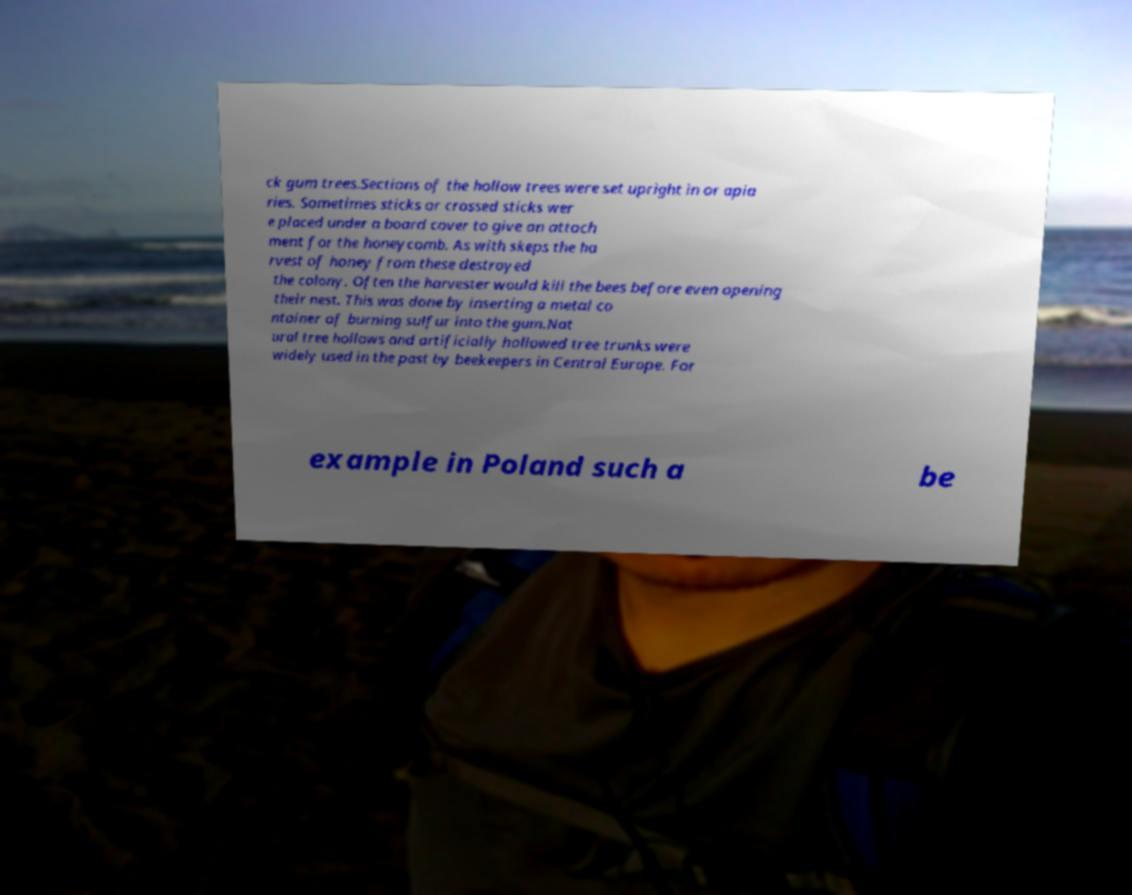Could you extract and type out the text from this image? ck gum trees.Sections of the hollow trees were set upright in or apia ries. Sometimes sticks or crossed sticks wer e placed under a board cover to give an attach ment for the honeycomb. As with skeps the ha rvest of honey from these destroyed the colony. Often the harvester would kill the bees before even opening their nest. This was done by inserting a metal co ntainer of burning sulfur into the gum.Nat ural tree hollows and artificially hollowed tree trunks were widely used in the past by beekeepers in Central Europe. For example in Poland such a be 